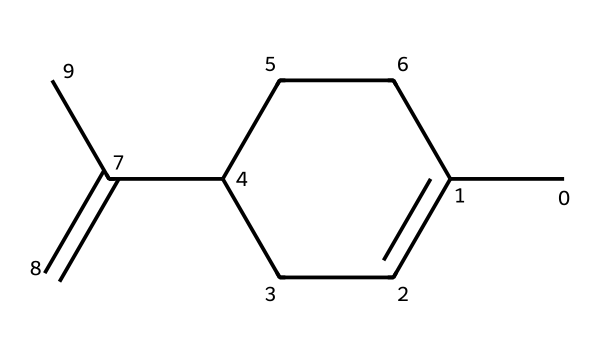What is the IUPAC name of this chemical? The SMILES representation indicates a structure with six carbon atoms in a ring and an additional two carbon atoms connected by a double bond, which corresponds to the chemical known as limonene.
Answer: limonene How many carbon atoms are present in the structure? By analyzing the SMILES representation, we see there are eight carbon atoms (C) represented. Counting all C’s shows that there are 8 in total.
Answer: 8 How many double bonds are there in this molecule? The structure contains one double bond between the two carbon atoms indicated by the "C(=C)" notation in the SMILES, which signifies a double bond present.
Answer: 1 What type of compound is limonene classified as? Limonene is a type of terpene, which is characterized by its specific structure that includes multiple carbon atoms and functional groups typically associated with aromatic properties.
Answer: terpene What is the functional group associated with limonene? There are no functional groups like hydroxyl (–OH) or carboxyl (–COOH) present in the limonene structure; however, it has a double bond indicative of an alkene group.
Answer: alkene Why is limonene considered important in industrial applications? Limonene's structure allows it to act as a solvent and cleaner, making it valued for its chemical properties that enable dissolving, cleaning, and aromatic uses in various products.
Answer: solvent 